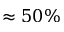Convert formula to latex. <formula><loc_0><loc_0><loc_500><loc_500>\approx 5 0 \%</formula> 